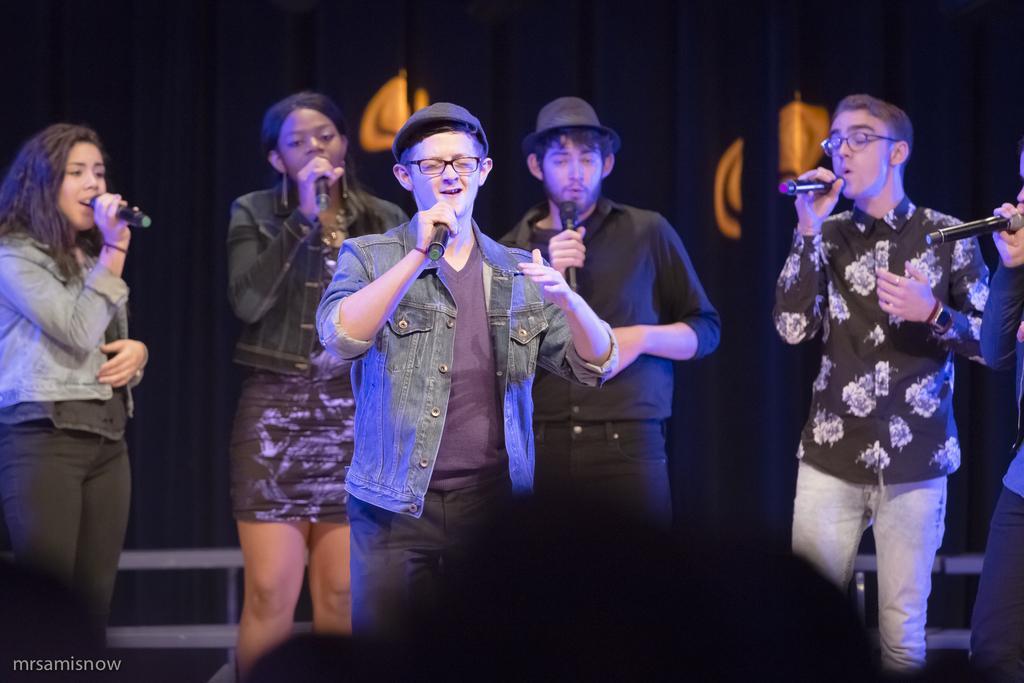Describe this image in one or two sentences. Here men and women are holding microphone. 